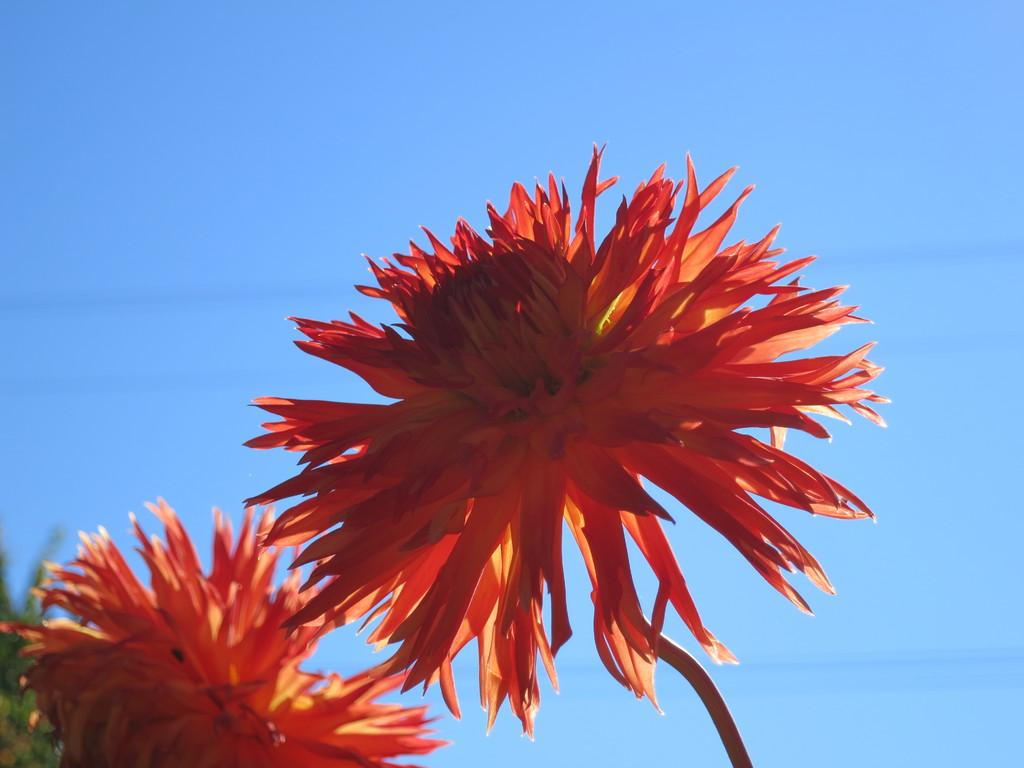What types of vegetation can be seen in the image? There are flowers and plants in the image. What can be seen in the background of the image? The sky is visible in the background of the image. How many rays are visible coming from the sun in the image? There is no sun visible in the image, so it is not possible to determine how many rays might be present. 